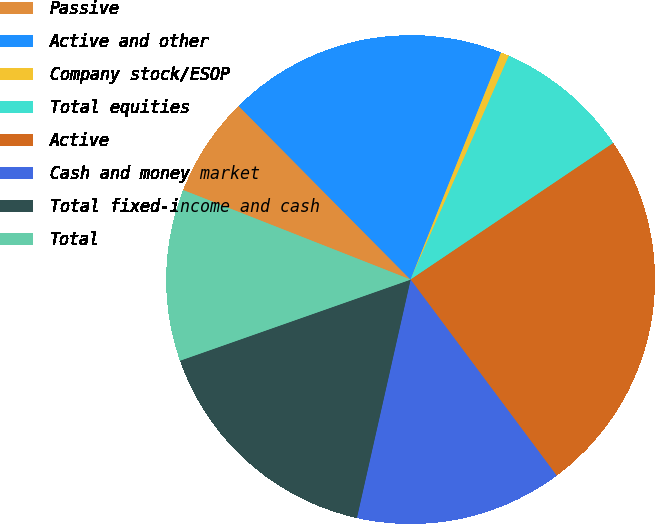<chart> <loc_0><loc_0><loc_500><loc_500><pie_chart><fcel>Passive<fcel>Active and other<fcel>Company stock/ESOP<fcel>Total equities<fcel>Active<fcel>Cash and money market<fcel>Total fixed-income and cash<fcel>Total<nl><fcel>6.61%<fcel>18.46%<fcel>0.55%<fcel>8.98%<fcel>24.24%<fcel>13.72%<fcel>16.09%<fcel>11.35%<nl></chart> 